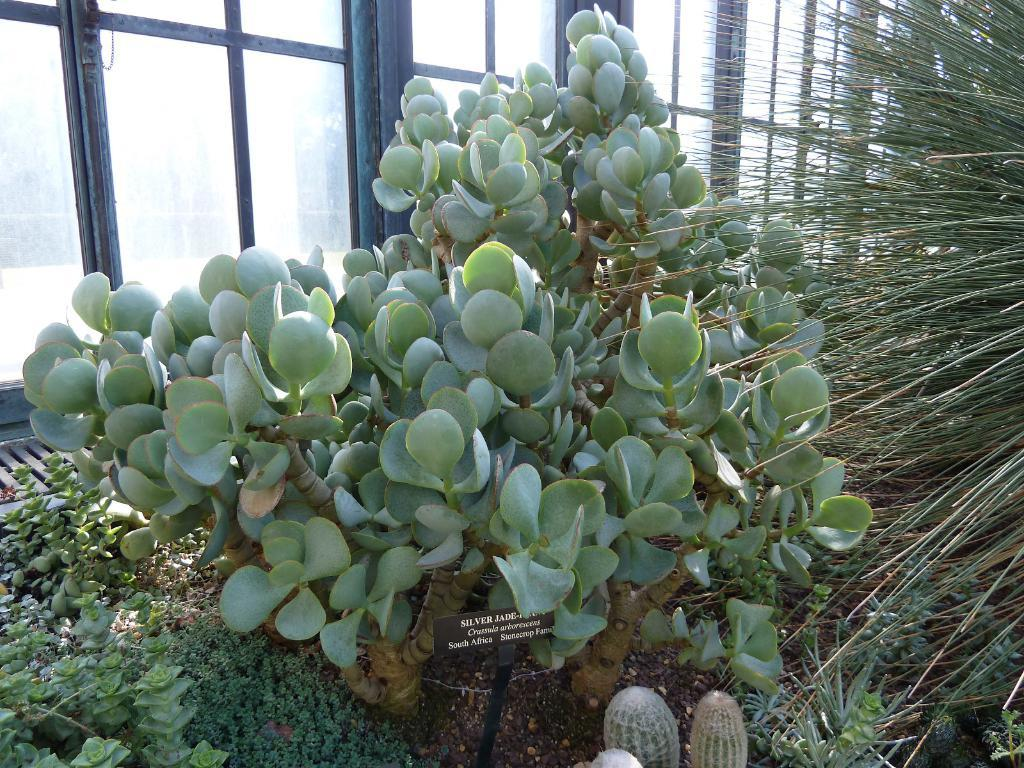What type of living organisms can be seen in the image? Plants can be seen in the image. What architectural feature is present on the left side of the image? There are glass doors on the left side of the image. What type of canvas is being used to paint the weather in the image? There is no canvas or painting of the weather present in the image. 